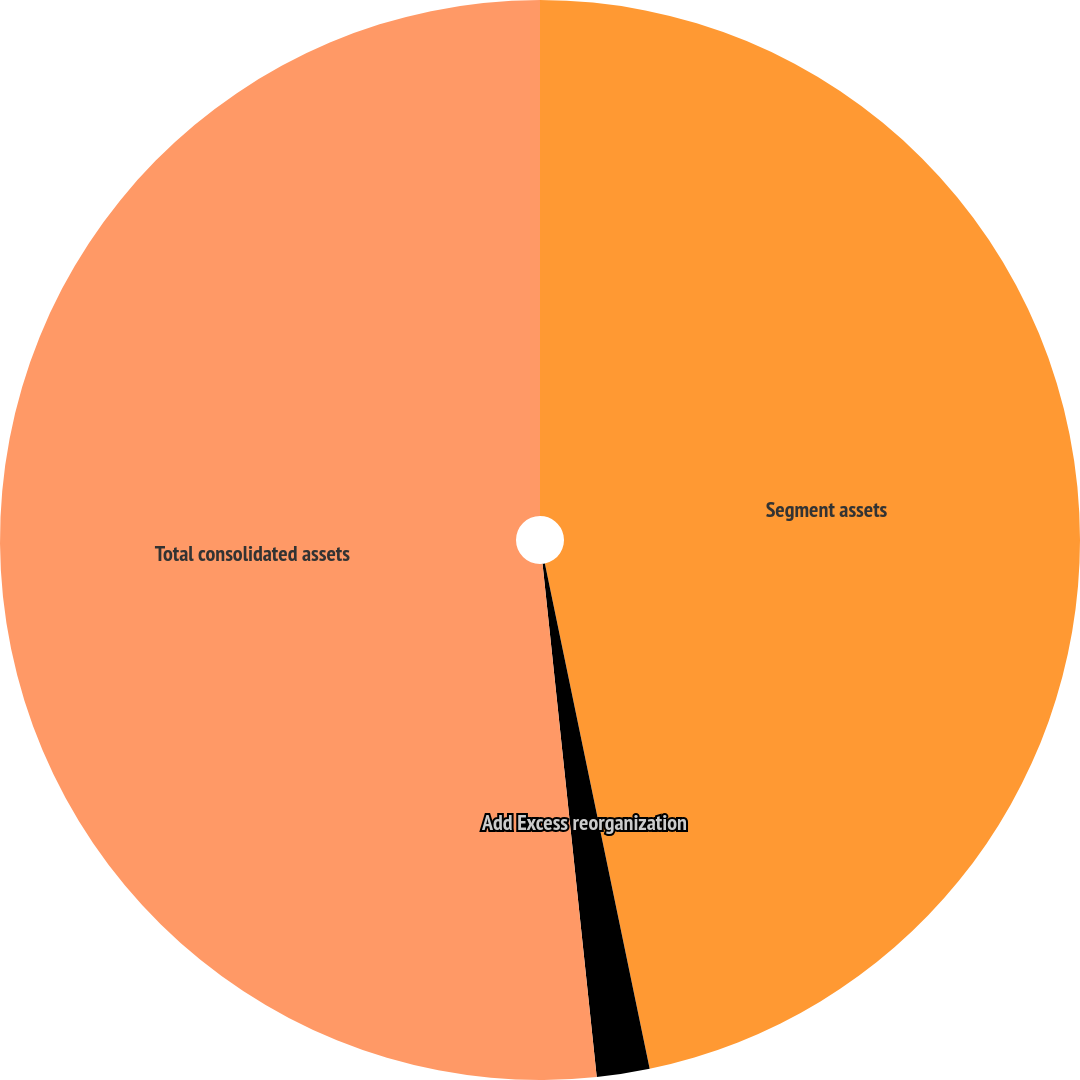<chart> <loc_0><loc_0><loc_500><loc_500><pie_chart><fcel>Segment assets<fcel>Add Excess reorganization<fcel>Total consolidated assets<nl><fcel>46.74%<fcel>1.58%<fcel>51.67%<nl></chart> 